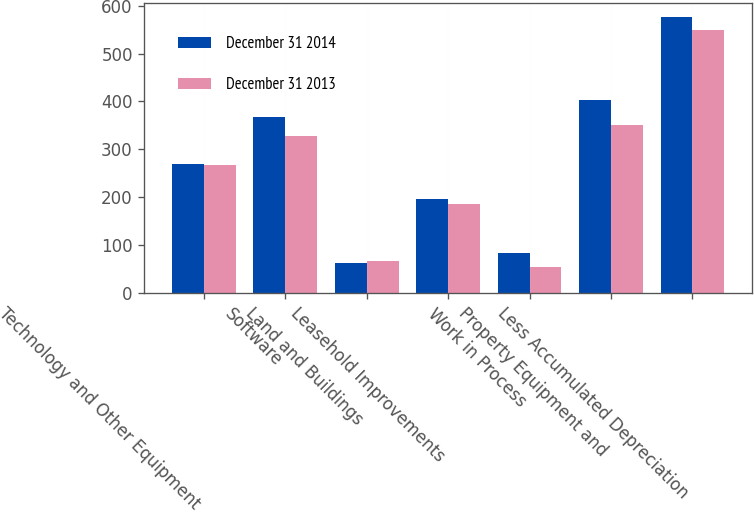<chart> <loc_0><loc_0><loc_500><loc_500><stacked_bar_chart><ecel><fcel>Technology and Other Equipment<fcel>Software<fcel>Land and Buildings<fcel>Leasehold Improvements<fcel>Work in Process<fcel>Property Equipment and<fcel>Less Accumulated Depreciation<nl><fcel>December 31 2014<fcel>268.9<fcel>368.3<fcel>62.3<fcel>196.1<fcel>84<fcel>402.6<fcel>577<nl><fcel>December 31 2013<fcel>266.5<fcel>327.8<fcel>65.8<fcel>185.7<fcel>54.4<fcel>350.8<fcel>549.4<nl></chart> 